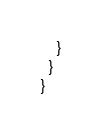Convert code to text. <code><loc_0><loc_0><loc_500><loc_500><_Scala_>    }
  }
}
</code> 